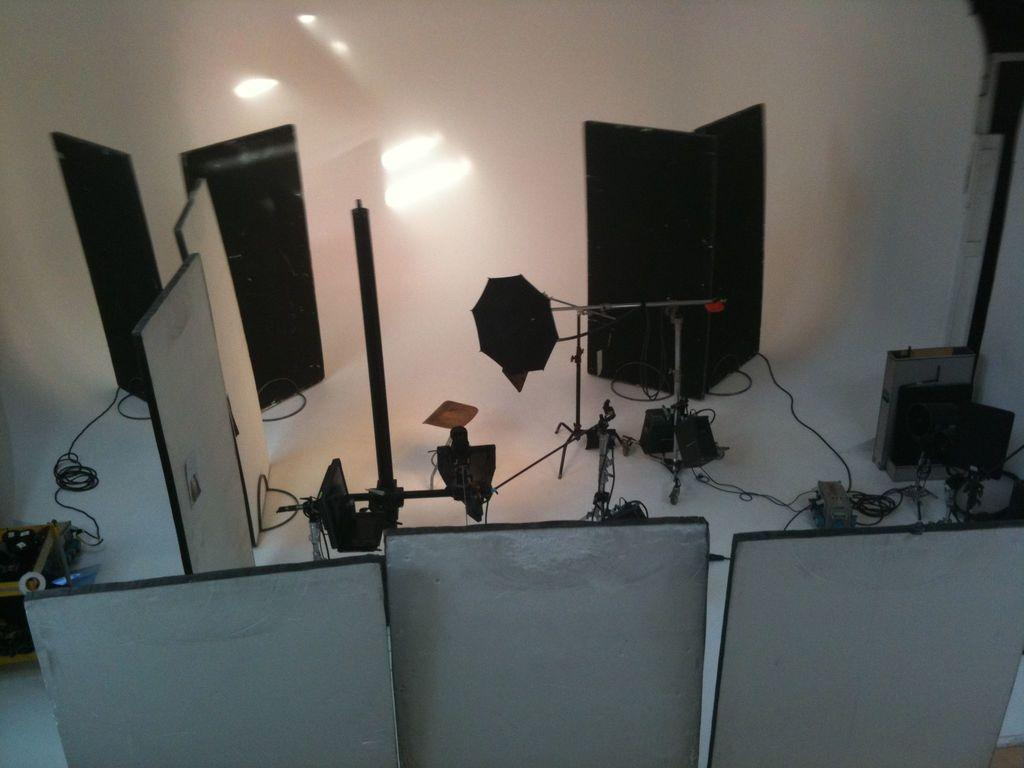What type of material is used for the boards at the bottom of the image? The boards at the bottom of the image are made of wood. Where are more wooden boards located in the image? There are wooden boards on the left side of the image. What else can be seen in the image besides the wooden boards? There are wires and camera holders in the image. How many bricks are stacked on top of the wooden boards in the image? There are no bricks present in the image; it only features wooden boards, wires, and camera holders. Can you spot an owl perched on the wooden boards in the image? There is no owl present in the image. 